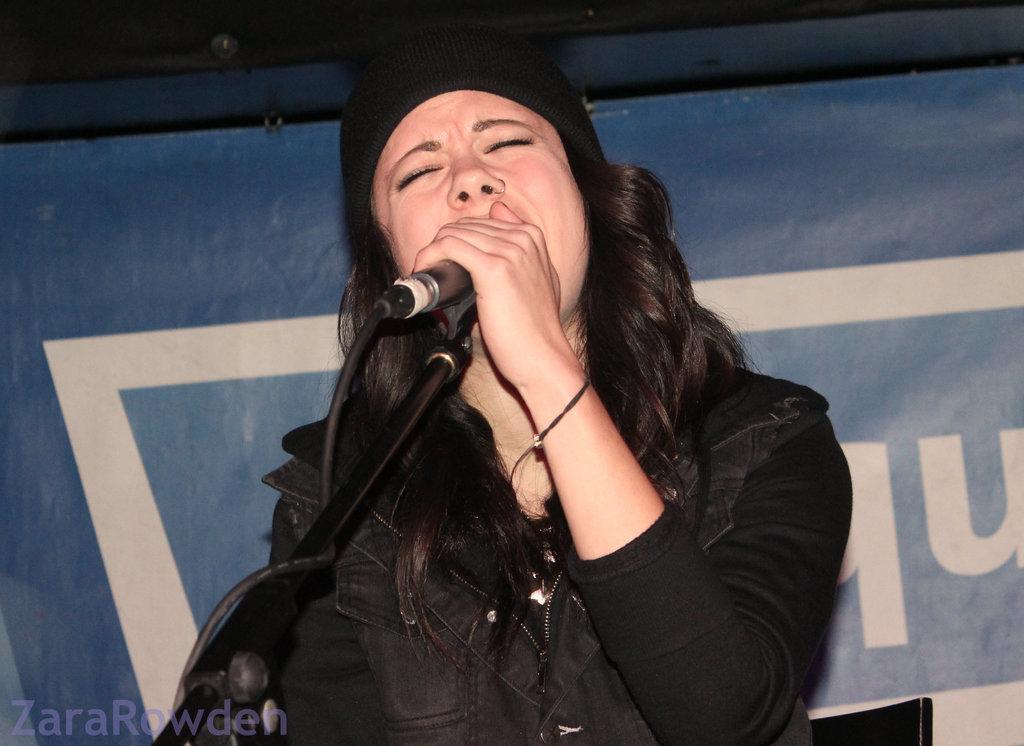Could you give a brief overview of what you see in this image? In the image we can see there is a woman standing and she is holding mic in her hand. The mic is kept on the stand and the woman is wearing black colour jacket. Behind there is banner and the woman is wearing hand band on her hand. 